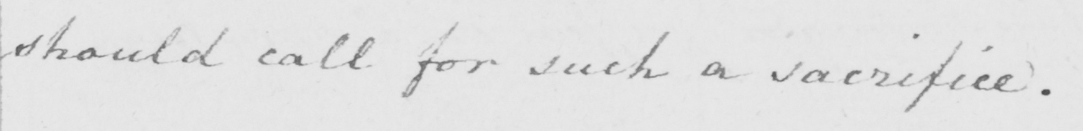What is written in this line of handwriting? should call for such a sacrifice . 